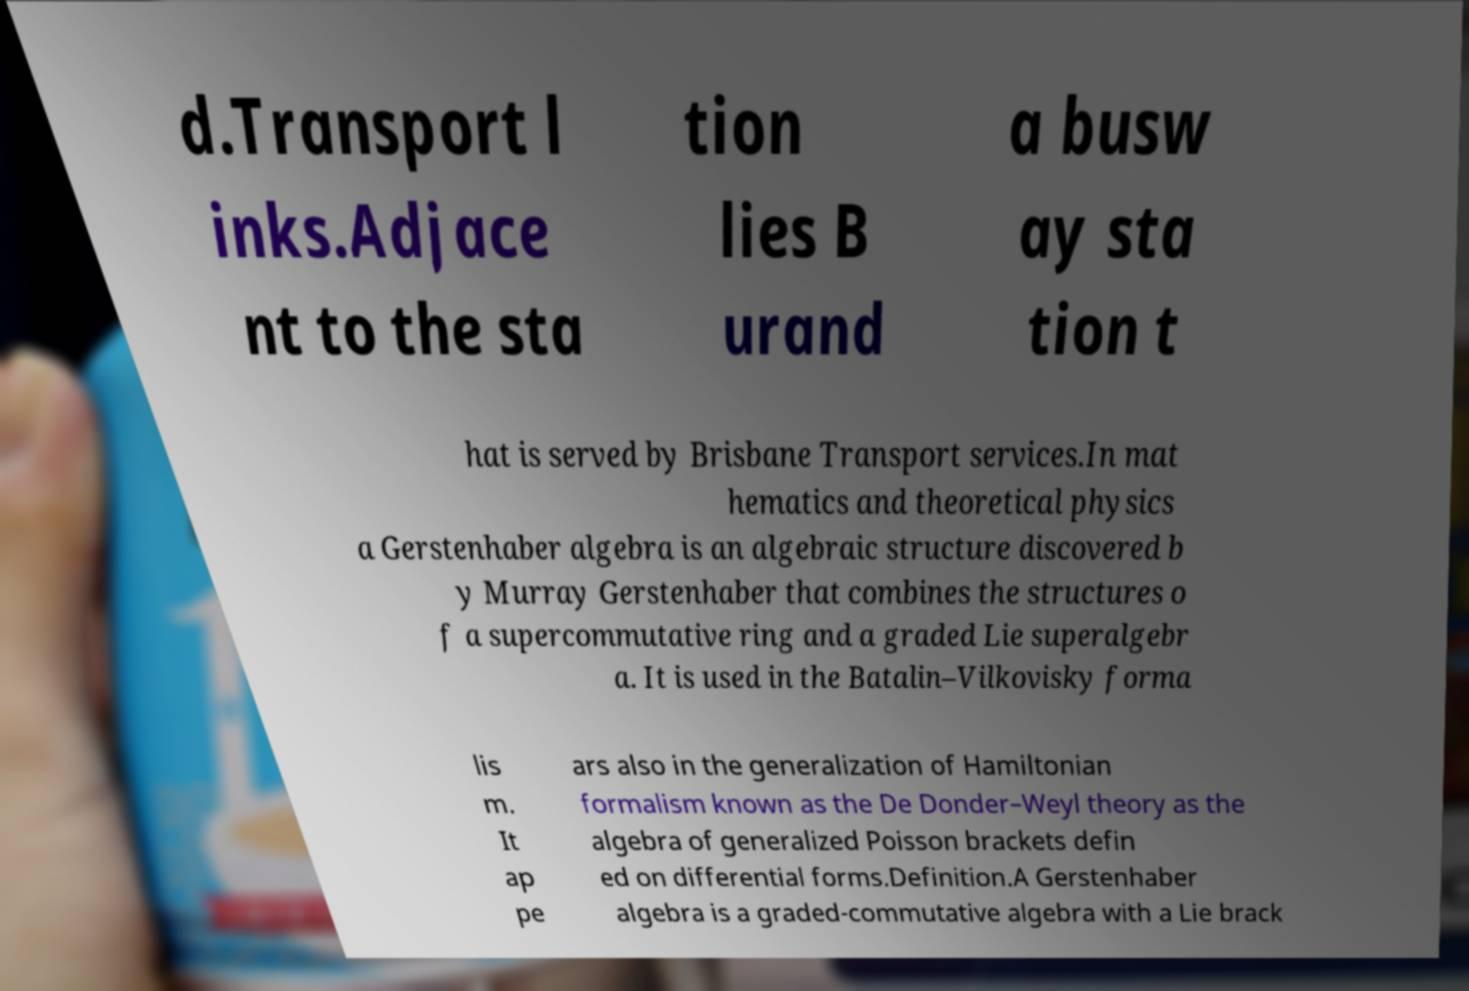For documentation purposes, I need the text within this image transcribed. Could you provide that? d.Transport l inks.Adjace nt to the sta tion lies B urand a busw ay sta tion t hat is served by Brisbane Transport services.In mat hematics and theoretical physics a Gerstenhaber algebra is an algebraic structure discovered b y Murray Gerstenhaber that combines the structures o f a supercommutative ring and a graded Lie superalgebr a. It is used in the Batalin–Vilkovisky forma lis m. It ap pe ars also in the generalization of Hamiltonian formalism known as the De Donder–Weyl theory as the algebra of generalized Poisson brackets defin ed on differential forms.Definition.A Gerstenhaber algebra is a graded-commutative algebra with a Lie brack 